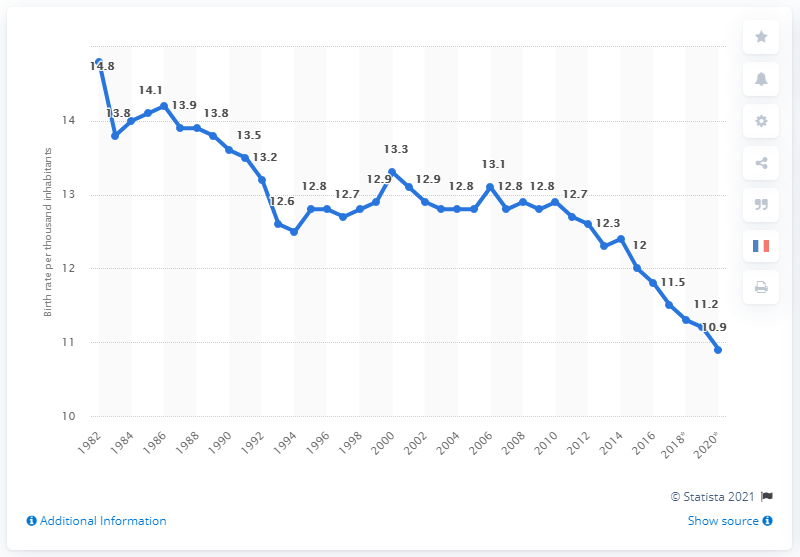List a handful of essential elements in this visual. In 1986, the birth rate in France was 14.2 per 1,000 inhabitants. In 1986, the highest birth rate was recorded in France. 